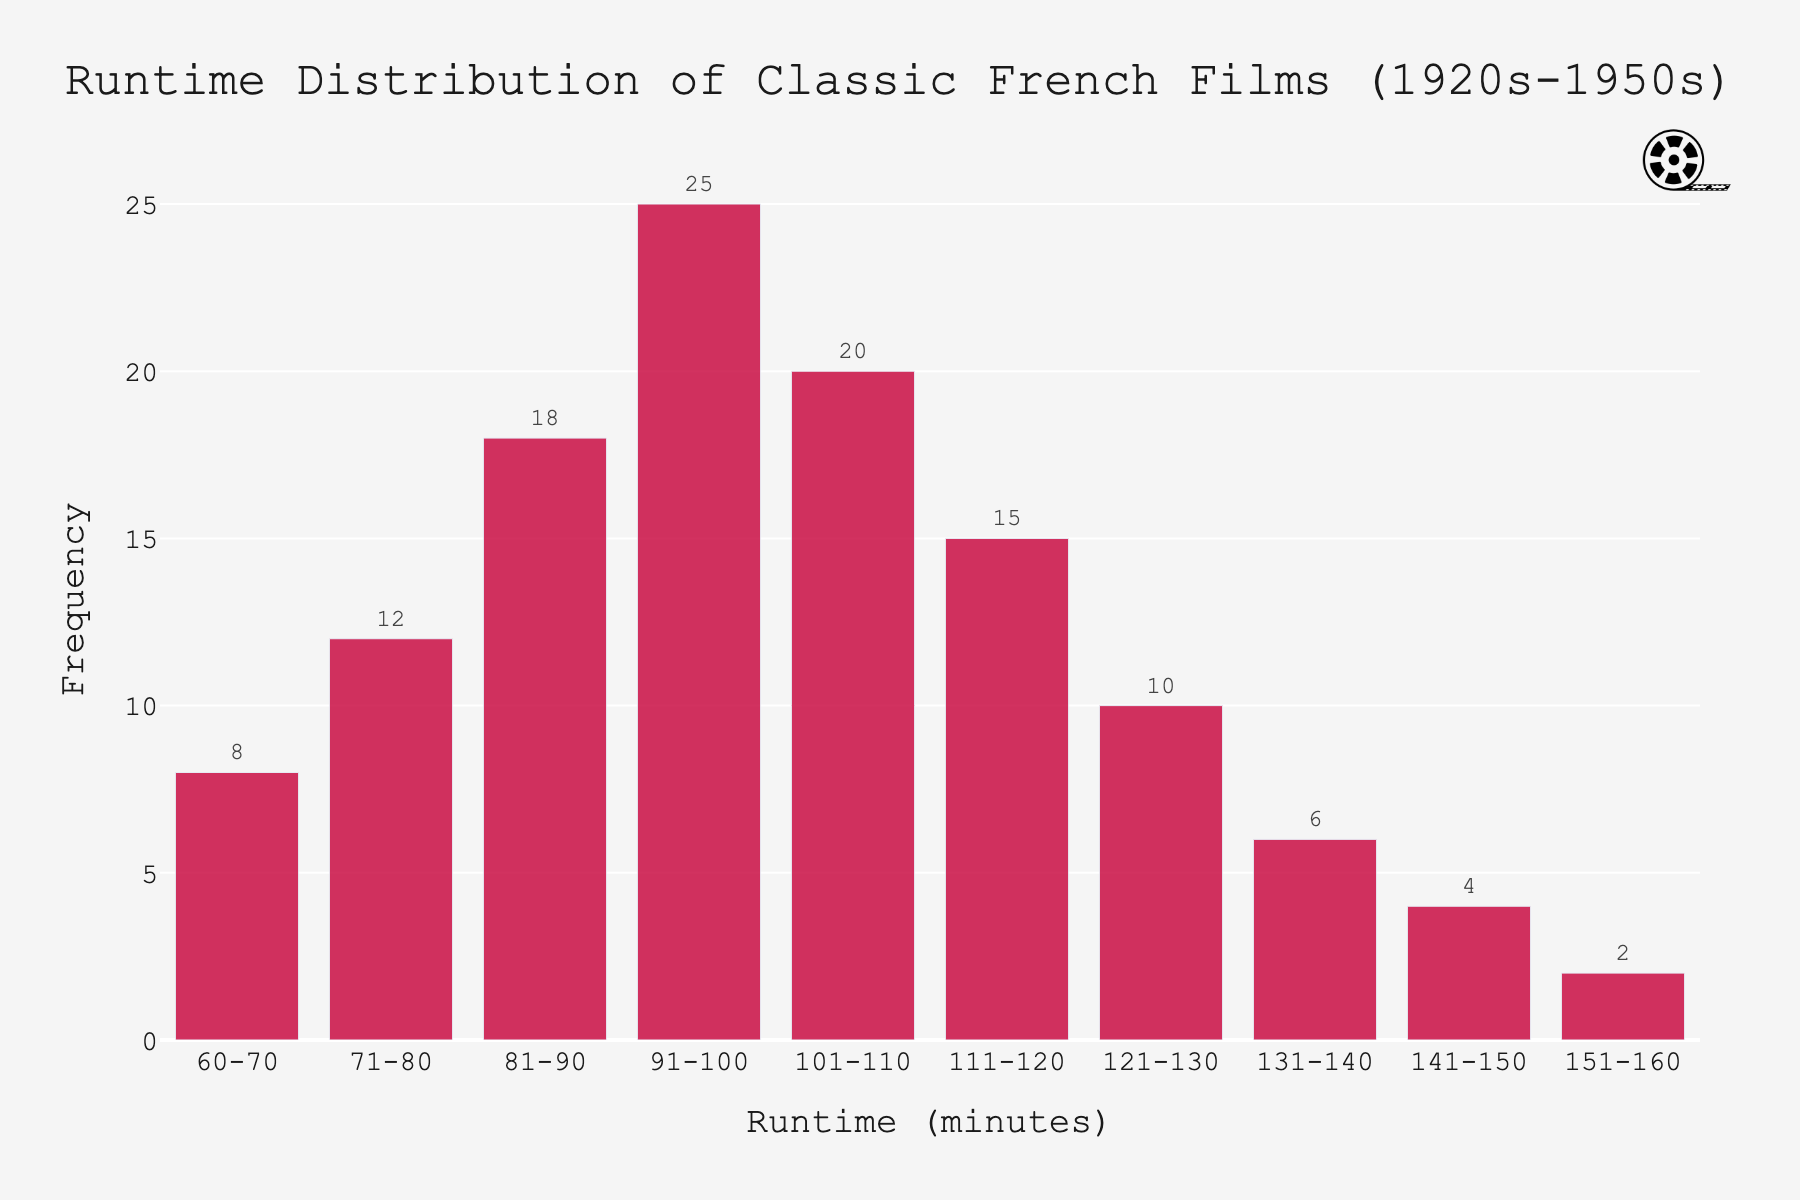What is the title of the histogram? The title of the histogram is given at the top center of the figure. It reads "Runtime Distribution of Classic French Films (1920s-1950s)".
Answer: Runtime Distribution of Classic French Films (1920s-1950s) Which runtime interval has the highest frequency? By looking at the bars in the histogram, the bar for the interval "91-100" minutes is the tallest. Therefore, this interval has the highest frequency.
Answer: 91-100 minutes How many films have a runtime between 111 minutes and 120 minutes? The bar corresponding to the "111-120" minutes interval shows a frequency of 15.
Answer: 15 What is the total number of films represented in the histogram? To find the total number of films, sum the frequencies of all runtime intervals: 8 + 12 + 18 + 25 + 20 + 15 + 10 + 6 + 4 + 2. This equals 120.
Answer: 120 What is the difference in frequency between the intervals "81-90" minutes and "101-110" minutes? The frequency for the "81-90" interval is 18, and for the "101-110" interval it is 20. Subtracting these gives 20 - 18 = 2.
Answer: 2 Are there more films with a runtime below 90 minutes or those with a runtime above 110 minutes? Calculate total frequencies for runtimes below 90 minutes: 8 + 12 + 18 = 38. Calculate those above 110 minutes: 15 + 10 + 6 + 4 + 2 = 37. Comparing these, there are more films below 90 minutes.
Answer: Below 90 minutes What percentage of films have a runtime between 91 and 120 minutes? Frequencies for "91-100", "101-110", and "111-120" intervals: 25 + 20 + 15 = 60. Total films = 120. So, (60/120) * 100 = 50%.
Answer: 50% What's the average frequency of the runtime intervals? Total number of intervals is 10. Total number of films is 120. Average frequency = Total frequency / Number of intervals = 120 / 10 = 12.
Answer: 12 Which interval represents the least common runtime? The bar for the "151-160" minutes interval is the shortest, indicating a frequency of 2.
Answer: 151-160 minutes 